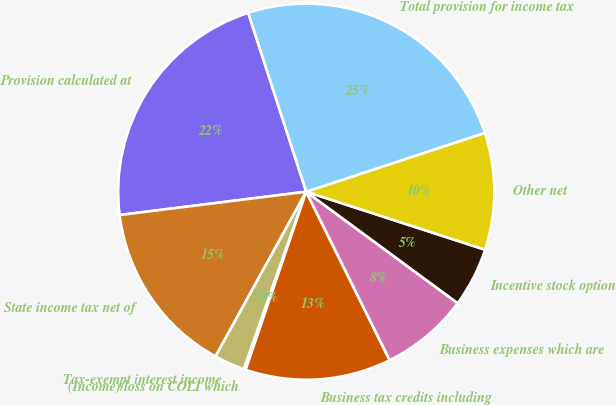Convert chart. <chart><loc_0><loc_0><loc_500><loc_500><pie_chart><fcel>Provision calculated at<fcel>State income tax net of<fcel>Tax-exempt interest income<fcel>(Income)/loss on COLI which<fcel>Business tax credits including<fcel>Business expenses which are<fcel>Incentive stock option<fcel>Other net<fcel>Total provision for income tax<nl><fcel>21.99%<fcel>15.01%<fcel>2.63%<fcel>0.16%<fcel>12.54%<fcel>7.58%<fcel>5.11%<fcel>10.06%<fcel>24.92%<nl></chart> 